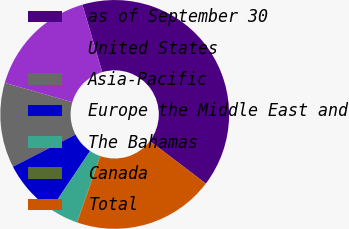Convert chart to OTSL. <chart><loc_0><loc_0><loc_500><loc_500><pie_chart><fcel>as of September 30<fcel>United States<fcel>Asia-Pacific<fcel>Europe the Middle East and<fcel>The Bahamas<fcel>Canada<fcel>Total<nl><fcel>39.89%<fcel>15.99%<fcel>12.01%<fcel>8.03%<fcel>4.04%<fcel>0.06%<fcel>19.98%<nl></chart> 